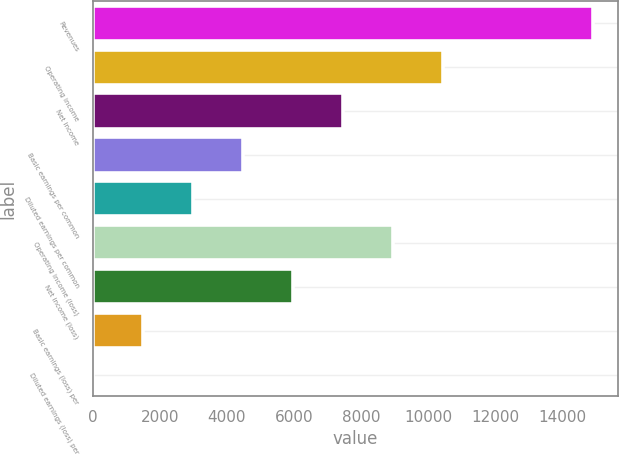Convert chart to OTSL. <chart><loc_0><loc_0><loc_500><loc_500><bar_chart><fcel>Revenues<fcel>Operating income<fcel>Net income<fcel>Basic earnings per common<fcel>Diluted earnings per common<fcel>Operating income (loss)<fcel>Net income (loss)<fcel>Basic earnings (loss) per<fcel>Diluted earnings (loss) per<nl><fcel>14931<fcel>10452.5<fcel>7466.74<fcel>4481.02<fcel>2988.16<fcel>8959.6<fcel>5973.88<fcel>1495.3<fcel>2.44<nl></chart> 